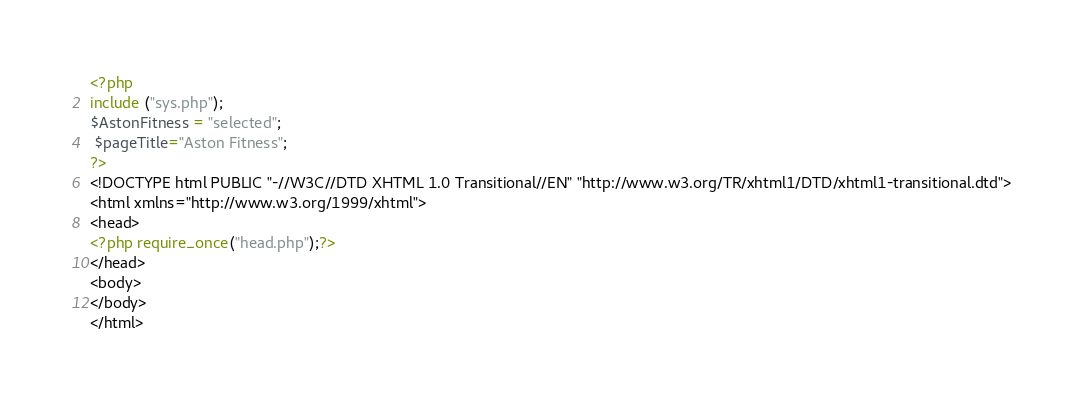<code> <loc_0><loc_0><loc_500><loc_500><_PHP_><?php
include ("sys.php");
$AstonFitness = "selected";
 $pageTitle="Aston Fitness";
?>
<!DOCTYPE html PUBLIC "-//W3C//DTD XHTML 1.0 Transitional//EN" "http://www.w3.org/TR/xhtml1/DTD/xhtml1-transitional.dtd">
<html xmlns="http://www.w3.org/1999/xhtml">
<head>
<?php require_once("head.php");?>
</head>
<body>
</body>
</html></code> 